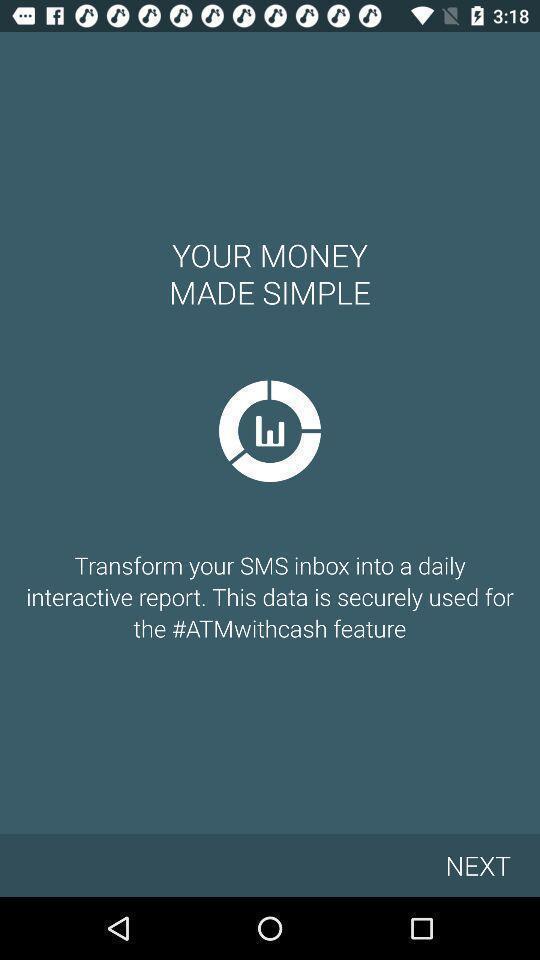Provide a description of this screenshot. Welcome page of the app. 